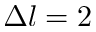Convert formula to latex. <formula><loc_0><loc_0><loc_500><loc_500>\Delta l = 2</formula> 